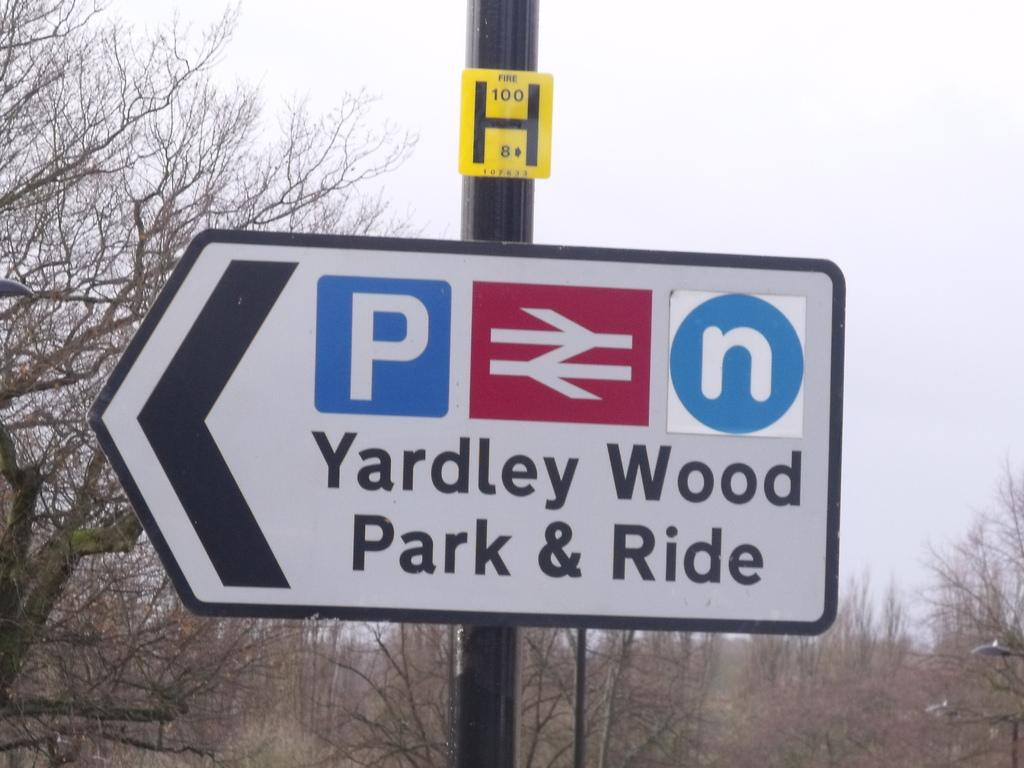<image>
Describe the image concisely. A sign for Yardley Wood Park and Ride points to the left. 